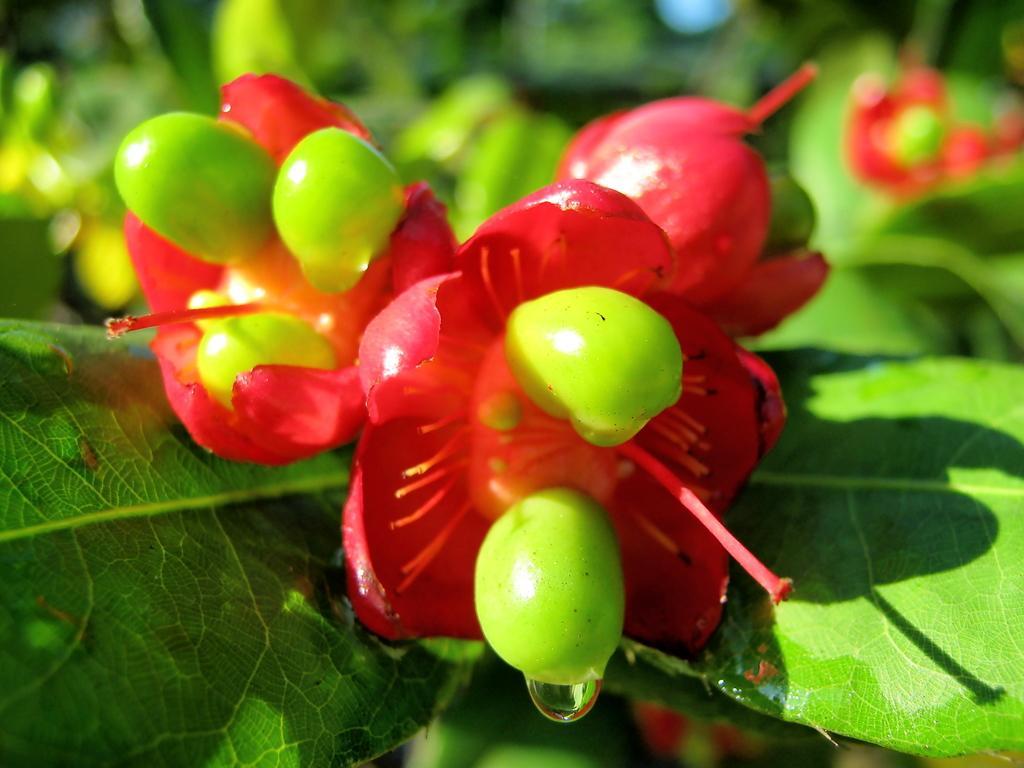Describe this image in one or two sentences. In this picture we can see some leaves and flowers, there is a blurry background. 